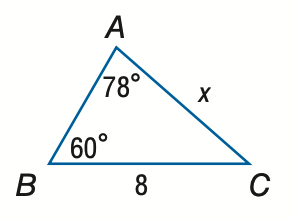Answer the mathemtical geometry problem and directly provide the correct option letter.
Question: Find x. Round to the nearest tenth.
Choices: A: 3.3 B: 7.1 C: 9.0 D: 19.2 B 